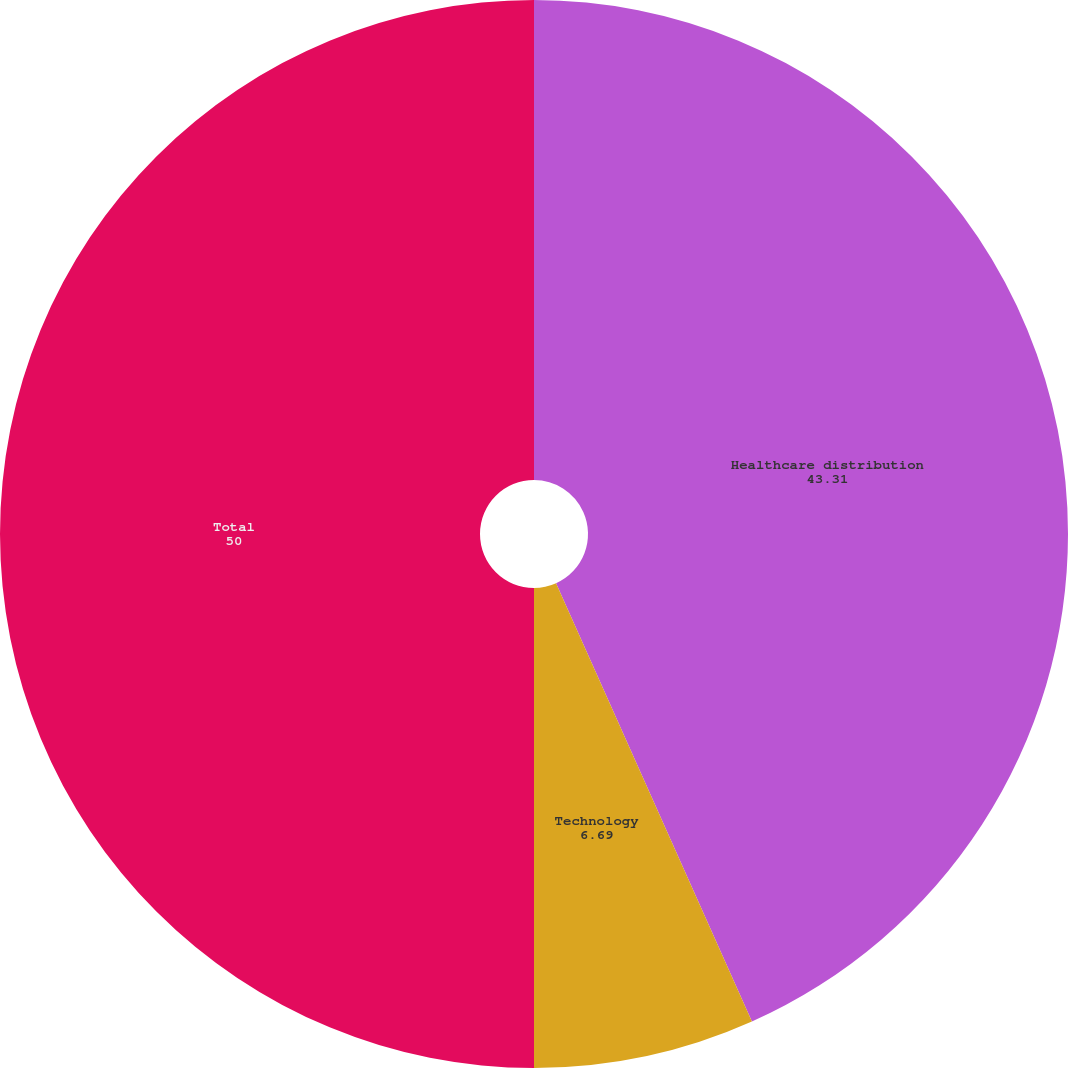Convert chart to OTSL. <chart><loc_0><loc_0><loc_500><loc_500><pie_chart><fcel>Healthcare distribution<fcel>Technology<fcel>Total<nl><fcel>43.31%<fcel>6.69%<fcel>50.0%<nl></chart> 